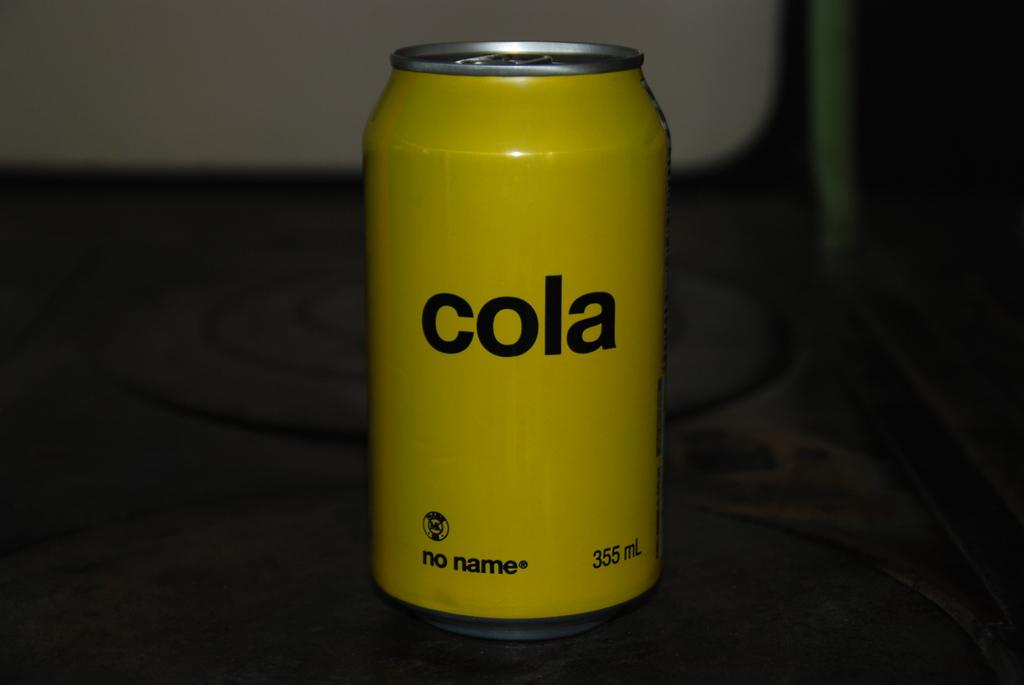Provide a one-sentence caption for the provided image. A single plain yellow can with the label "cola" is on the table. 